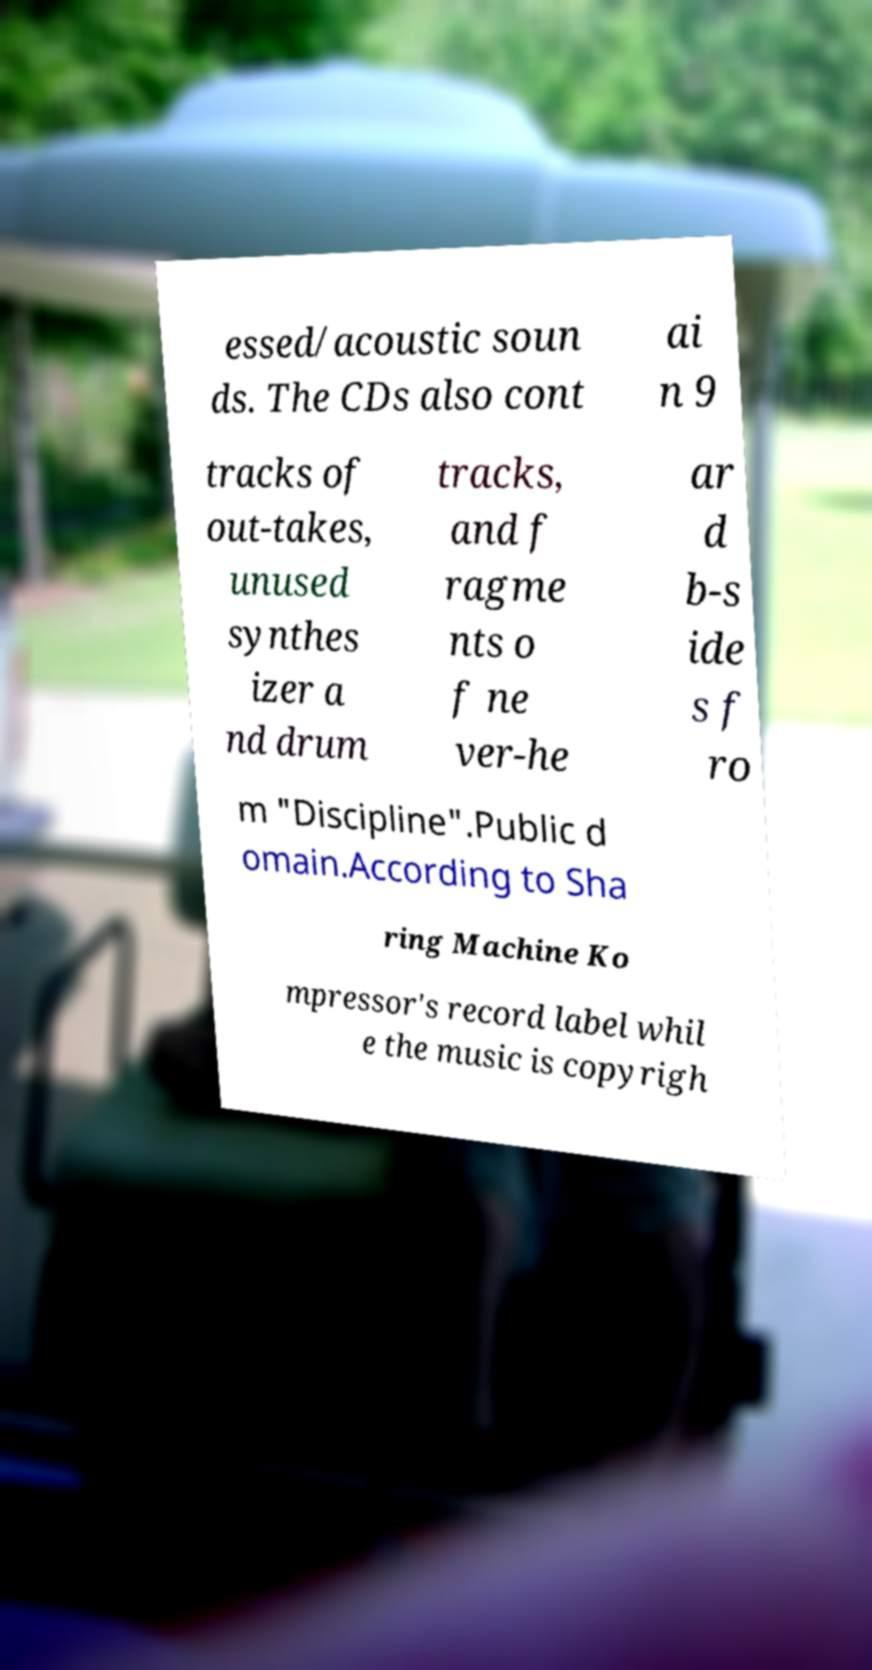There's text embedded in this image that I need extracted. Can you transcribe it verbatim? essed/acoustic soun ds. The CDs also cont ai n 9 tracks of out-takes, unused synthes izer a nd drum tracks, and f ragme nts o f ne ver-he ar d b-s ide s f ro m "Discipline".Public d omain.According to Sha ring Machine Ko mpressor's record label whil e the music is copyrigh 